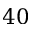Convert formula to latex. <formula><loc_0><loc_0><loc_500><loc_500>4 0</formula> 